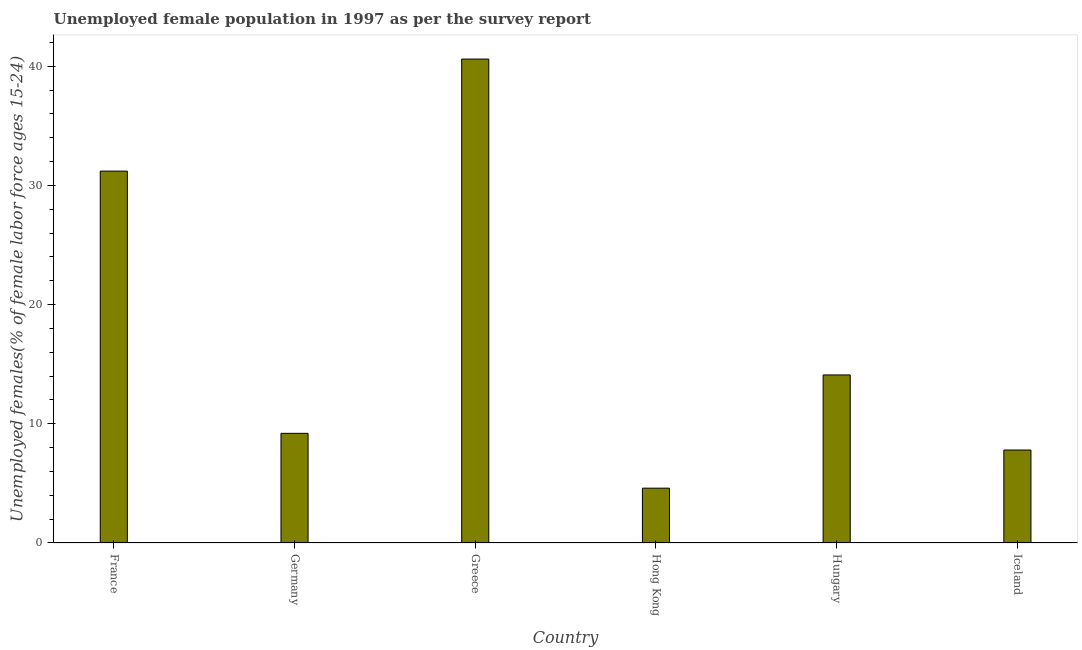What is the title of the graph?
Your answer should be very brief. Unemployed female population in 1997 as per the survey report. What is the label or title of the Y-axis?
Keep it short and to the point. Unemployed females(% of female labor force ages 15-24). What is the unemployed female youth in Germany?
Your answer should be very brief. 9.2. Across all countries, what is the maximum unemployed female youth?
Ensure brevity in your answer.  40.6. Across all countries, what is the minimum unemployed female youth?
Offer a very short reply. 4.6. In which country was the unemployed female youth maximum?
Provide a succinct answer. Greece. In which country was the unemployed female youth minimum?
Give a very brief answer. Hong Kong. What is the sum of the unemployed female youth?
Your answer should be very brief. 107.5. What is the difference between the unemployed female youth in Germany and Iceland?
Provide a short and direct response. 1.4. What is the average unemployed female youth per country?
Your response must be concise. 17.92. What is the median unemployed female youth?
Offer a very short reply. 11.65. In how many countries, is the unemployed female youth greater than 24 %?
Provide a succinct answer. 2. What is the ratio of the unemployed female youth in France to that in Iceland?
Ensure brevity in your answer.  4. What is the difference between the highest and the lowest unemployed female youth?
Provide a succinct answer. 36. In how many countries, is the unemployed female youth greater than the average unemployed female youth taken over all countries?
Ensure brevity in your answer.  2. How many bars are there?
Offer a very short reply. 6. Are all the bars in the graph horizontal?
Offer a terse response. No. How many countries are there in the graph?
Your answer should be very brief. 6. Are the values on the major ticks of Y-axis written in scientific E-notation?
Provide a short and direct response. No. What is the Unemployed females(% of female labor force ages 15-24) of France?
Offer a terse response. 31.2. What is the Unemployed females(% of female labor force ages 15-24) in Germany?
Give a very brief answer. 9.2. What is the Unemployed females(% of female labor force ages 15-24) of Greece?
Keep it short and to the point. 40.6. What is the Unemployed females(% of female labor force ages 15-24) of Hong Kong?
Keep it short and to the point. 4.6. What is the Unemployed females(% of female labor force ages 15-24) of Hungary?
Your answer should be very brief. 14.1. What is the Unemployed females(% of female labor force ages 15-24) in Iceland?
Make the answer very short. 7.8. What is the difference between the Unemployed females(% of female labor force ages 15-24) in France and Germany?
Offer a terse response. 22. What is the difference between the Unemployed females(% of female labor force ages 15-24) in France and Greece?
Make the answer very short. -9.4. What is the difference between the Unemployed females(% of female labor force ages 15-24) in France and Hong Kong?
Your response must be concise. 26.6. What is the difference between the Unemployed females(% of female labor force ages 15-24) in France and Hungary?
Your response must be concise. 17.1. What is the difference between the Unemployed females(% of female labor force ages 15-24) in France and Iceland?
Ensure brevity in your answer.  23.4. What is the difference between the Unemployed females(% of female labor force ages 15-24) in Germany and Greece?
Your answer should be very brief. -31.4. What is the difference between the Unemployed females(% of female labor force ages 15-24) in Greece and Hong Kong?
Provide a succinct answer. 36. What is the difference between the Unemployed females(% of female labor force ages 15-24) in Greece and Hungary?
Offer a terse response. 26.5. What is the difference between the Unemployed females(% of female labor force ages 15-24) in Greece and Iceland?
Ensure brevity in your answer.  32.8. What is the difference between the Unemployed females(% of female labor force ages 15-24) in Hong Kong and Hungary?
Offer a terse response. -9.5. What is the difference between the Unemployed females(% of female labor force ages 15-24) in Hong Kong and Iceland?
Offer a terse response. -3.2. What is the difference between the Unemployed females(% of female labor force ages 15-24) in Hungary and Iceland?
Offer a very short reply. 6.3. What is the ratio of the Unemployed females(% of female labor force ages 15-24) in France to that in Germany?
Provide a succinct answer. 3.39. What is the ratio of the Unemployed females(% of female labor force ages 15-24) in France to that in Greece?
Keep it short and to the point. 0.77. What is the ratio of the Unemployed females(% of female labor force ages 15-24) in France to that in Hong Kong?
Your response must be concise. 6.78. What is the ratio of the Unemployed females(% of female labor force ages 15-24) in France to that in Hungary?
Your answer should be very brief. 2.21. What is the ratio of the Unemployed females(% of female labor force ages 15-24) in Germany to that in Greece?
Ensure brevity in your answer.  0.23. What is the ratio of the Unemployed females(% of female labor force ages 15-24) in Germany to that in Hungary?
Make the answer very short. 0.65. What is the ratio of the Unemployed females(% of female labor force ages 15-24) in Germany to that in Iceland?
Ensure brevity in your answer.  1.18. What is the ratio of the Unemployed females(% of female labor force ages 15-24) in Greece to that in Hong Kong?
Provide a short and direct response. 8.83. What is the ratio of the Unemployed females(% of female labor force ages 15-24) in Greece to that in Hungary?
Provide a succinct answer. 2.88. What is the ratio of the Unemployed females(% of female labor force ages 15-24) in Greece to that in Iceland?
Provide a succinct answer. 5.21. What is the ratio of the Unemployed females(% of female labor force ages 15-24) in Hong Kong to that in Hungary?
Provide a succinct answer. 0.33. What is the ratio of the Unemployed females(% of female labor force ages 15-24) in Hong Kong to that in Iceland?
Your response must be concise. 0.59. What is the ratio of the Unemployed females(% of female labor force ages 15-24) in Hungary to that in Iceland?
Give a very brief answer. 1.81. 